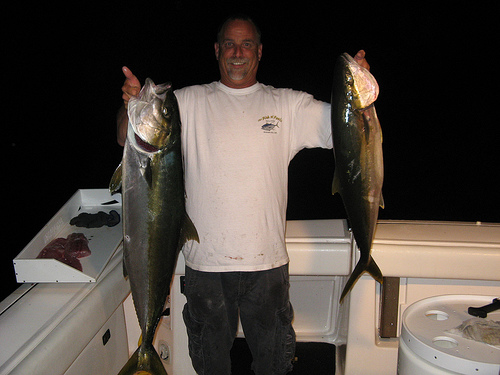<image>
Can you confirm if the man is to the left of the fish? Yes. From this viewpoint, the man is positioned to the left side relative to the fish. Is there a man under the fish? No. The man is not positioned under the fish. The vertical relationship between these objects is different. Where is the fish in relation to the fish? Is it next to the fish? Yes. The fish is positioned adjacent to the fish, located nearby in the same general area. 